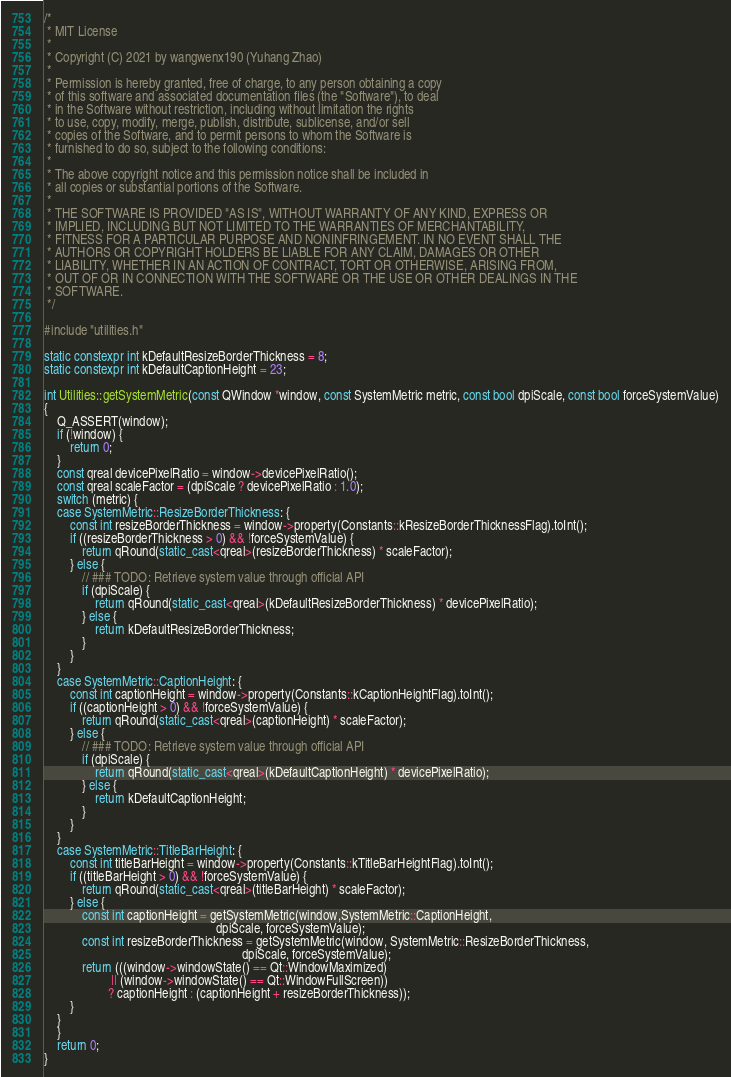Convert code to text. <code><loc_0><loc_0><loc_500><loc_500><_C++_>/*
 * MIT License
 *
 * Copyright (C) 2021 by wangwenx190 (Yuhang Zhao)
 *
 * Permission is hereby granted, free of charge, to any person obtaining a copy
 * of this software and associated documentation files (the "Software"), to deal
 * in the Software without restriction, including without limitation the rights
 * to use, copy, modify, merge, publish, distribute, sublicense, and/or sell
 * copies of the Software, and to permit persons to whom the Software is
 * furnished to do so, subject to the following conditions:
 *
 * The above copyright notice and this permission notice shall be included in
 * all copies or substantial portions of the Software.
 *
 * THE SOFTWARE IS PROVIDED "AS IS", WITHOUT WARRANTY OF ANY KIND, EXPRESS OR
 * IMPLIED, INCLUDING BUT NOT LIMITED TO THE WARRANTIES OF MERCHANTABILITY,
 * FITNESS FOR A PARTICULAR PURPOSE AND NONINFRINGEMENT. IN NO EVENT SHALL THE
 * AUTHORS OR COPYRIGHT HOLDERS BE LIABLE FOR ANY CLAIM, DAMAGES OR OTHER
 * LIABILITY, WHETHER IN AN ACTION OF CONTRACT, TORT OR OTHERWISE, ARISING FROM,
 * OUT OF OR IN CONNECTION WITH THE SOFTWARE OR THE USE OR OTHER DEALINGS IN THE
 * SOFTWARE.
 */

#include "utilities.h"

static constexpr int kDefaultResizeBorderThickness = 8;
static constexpr int kDefaultCaptionHeight = 23;

int Utilities::getSystemMetric(const QWindow *window, const SystemMetric metric, const bool dpiScale, const bool forceSystemValue)
{
    Q_ASSERT(window);
    if (!window) {
        return 0;
    }
    const qreal devicePixelRatio = window->devicePixelRatio();
    const qreal scaleFactor = (dpiScale ? devicePixelRatio : 1.0);
    switch (metric) {
    case SystemMetric::ResizeBorderThickness: {
        const int resizeBorderThickness = window->property(Constants::kResizeBorderThicknessFlag).toInt();
        if ((resizeBorderThickness > 0) && !forceSystemValue) {
            return qRound(static_cast<qreal>(resizeBorderThickness) * scaleFactor);
        } else {
            // ### TODO: Retrieve system value through official API
            if (dpiScale) {
                return qRound(static_cast<qreal>(kDefaultResizeBorderThickness) * devicePixelRatio);
            } else {
                return kDefaultResizeBorderThickness;
            }
        }
    }
    case SystemMetric::CaptionHeight: {
        const int captionHeight = window->property(Constants::kCaptionHeightFlag).toInt();
        if ((captionHeight > 0) && !forceSystemValue) {
            return qRound(static_cast<qreal>(captionHeight) * scaleFactor);
        } else {
            // ### TODO: Retrieve system value through official API
            if (dpiScale) {
                return qRound(static_cast<qreal>(kDefaultCaptionHeight) * devicePixelRatio);
            } else {
                return kDefaultCaptionHeight;
            }
        }
    }
    case SystemMetric::TitleBarHeight: {
        const int titleBarHeight = window->property(Constants::kTitleBarHeightFlag).toInt();
        if ((titleBarHeight > 0) && !forceSystemValue) {
            return qRound(static_cast<qreal>(titleBarHeight) * scaleFactor);
        } else {
            const int captionHeight = getSystemMetric(window,SystemMetric::CaptionHeight,
                                                      dpiScale, forceSystemValue);
            const int resizeBorderThickness = getSystemMetric(window, SystemMetric::ResizeBorderThickness,
                                                              dpiScale, forceSystemValue);
            return (((window->windowState() == Qt::WindowMaximized)
                     || (window->windowState() == Qt::WindowFullScreen))
                    ? captionHeight : (captionHeight + resizeBorderThickness));
        }
    }
    }
    return 0;
}
</code> 